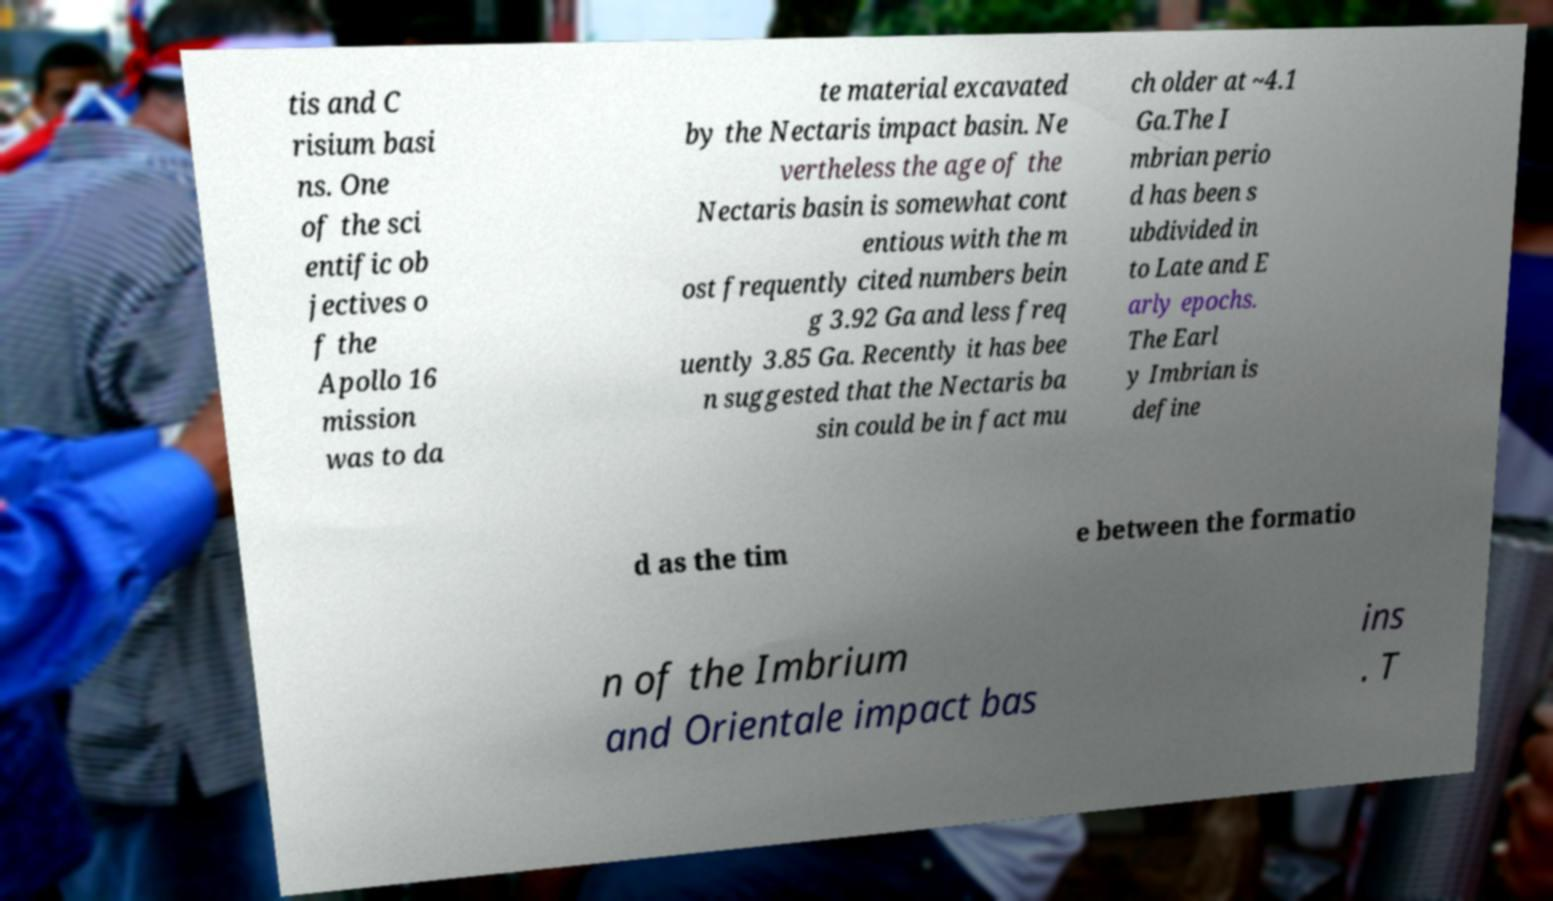What messages or text are displayed in this image? I need them in a readable, typed format. tis and C risium basi ns. One of the sci entific ob jectives o f the Apollo 16 mission was to da te material excavated by the Nectaris impact basin. Ne vertheless the age of the Nectaris basin is somewhat cont entious with the m ost frequently cited numbers bein g 3.92 Ga and less freq uently 3.85 Ga. Recently it has bee n suggested that the Nectaris ba sin could be in fact mu ch older at ~4.1 Ga.The I mbrian perio d has been s ubdivided in to Late and E arly epochs. The Earl y Imbrian is define d as the tim e between the formatio n of the Imbrium and Orientale impact bas ins . T 